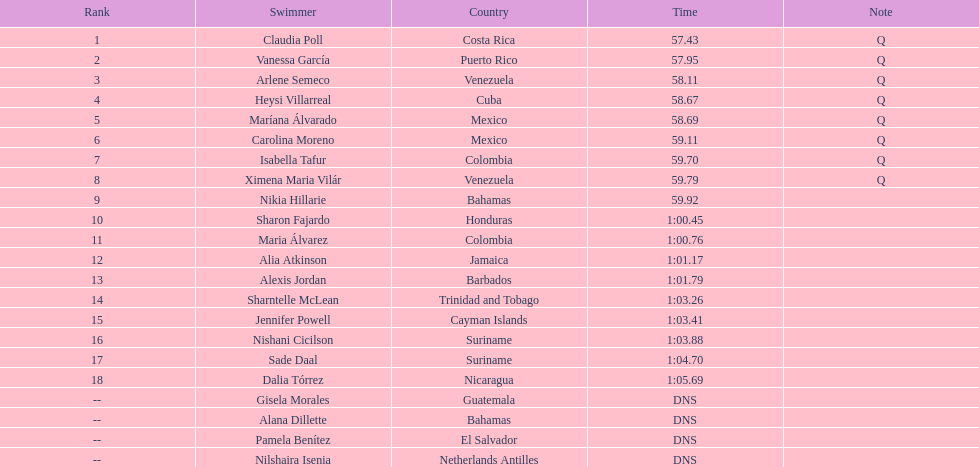How many swimmers are from mexico? 2. 